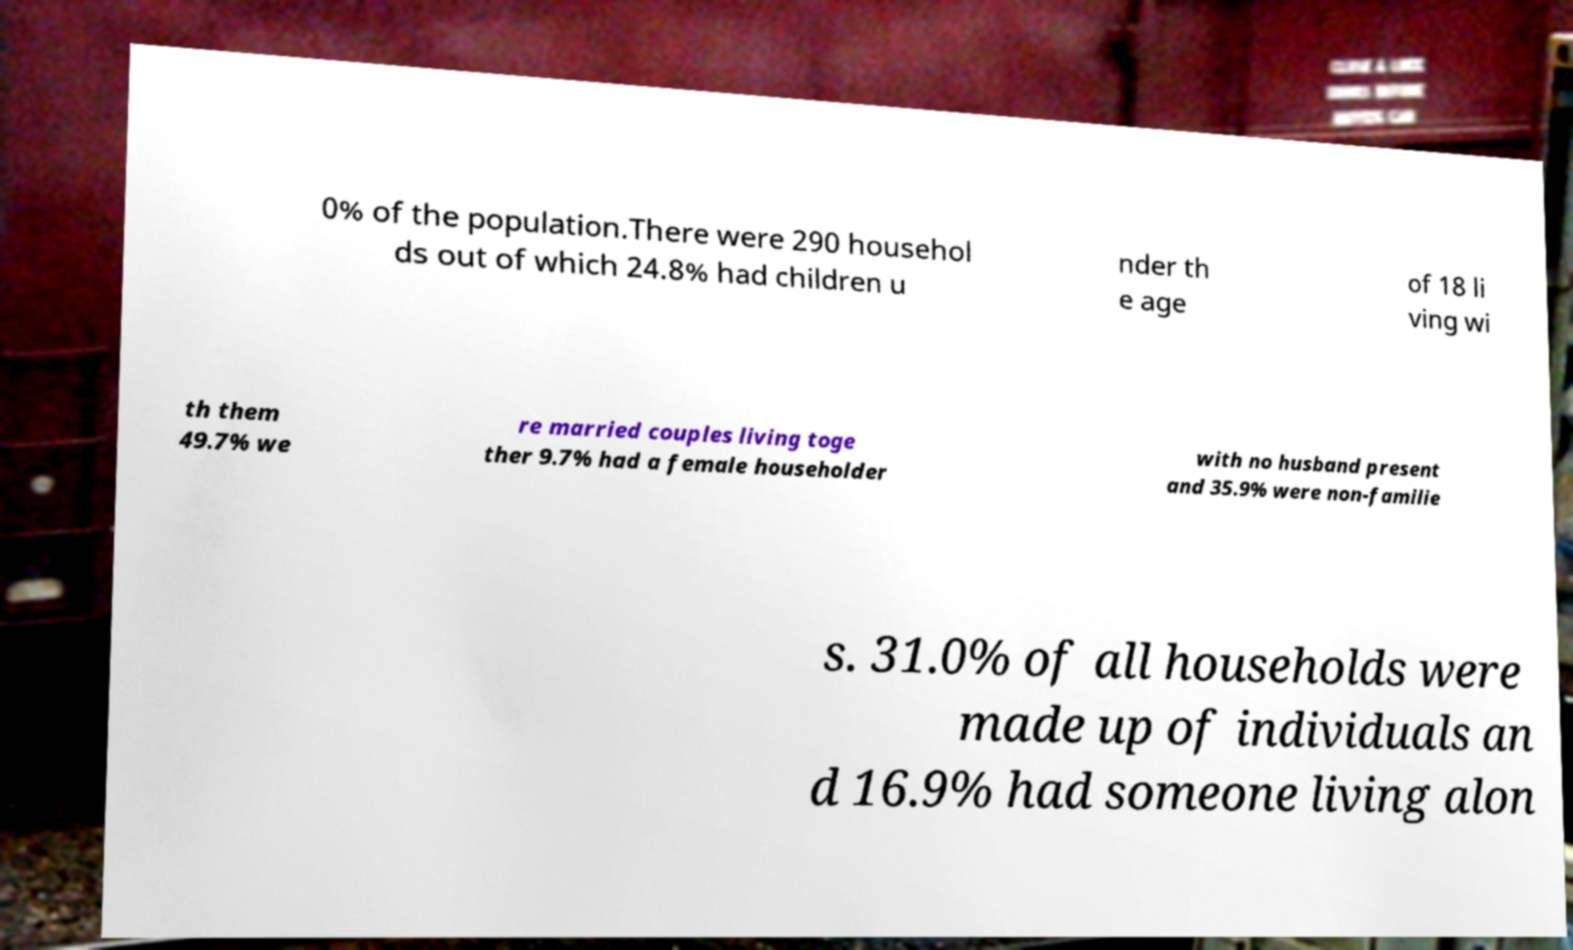I need the written content from this picture converted into text. Can you do that? 0% of the population.There were 290 househol ds out of which 24.8% had children u nder th e age of 18 li ving wi th them 49.7% we re married couples living toge ther 9.7% had a female householder with no husband present and 35.9% were non-familie s. 31.0% of all households were made up of individuals an d 16.9% had someone living alon 